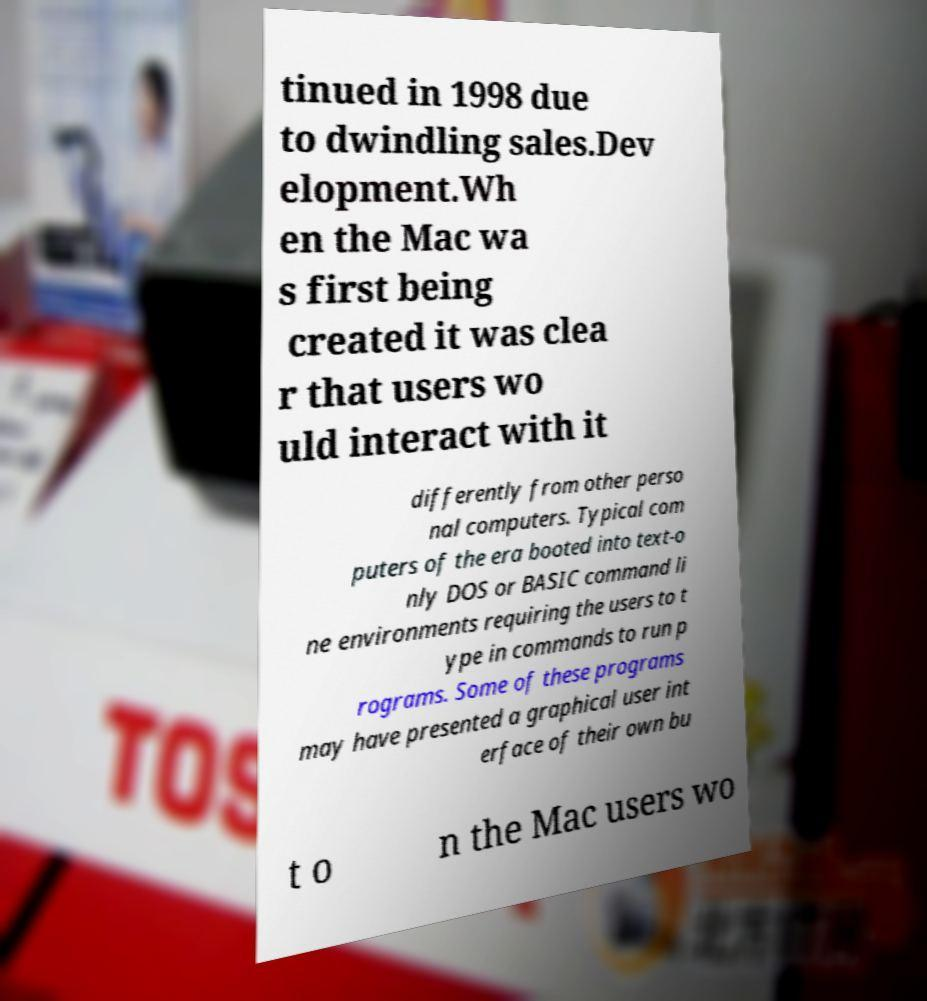Please identify and transcribe the text found in this image. tinued in 1998 due to dwindling sales.Dev elopment.Wh en the Mac wa s first being created it was clea r that users wo uld interact with it differently from other perso nal computers. Typical com puters of the era booted into text-o nly DOS or BASIC command li ne environments requiring the users to t ype in commands to run p rograms. Some of these programs may have presented a graphical user int erface of their own bu t o n the Mac users wo 